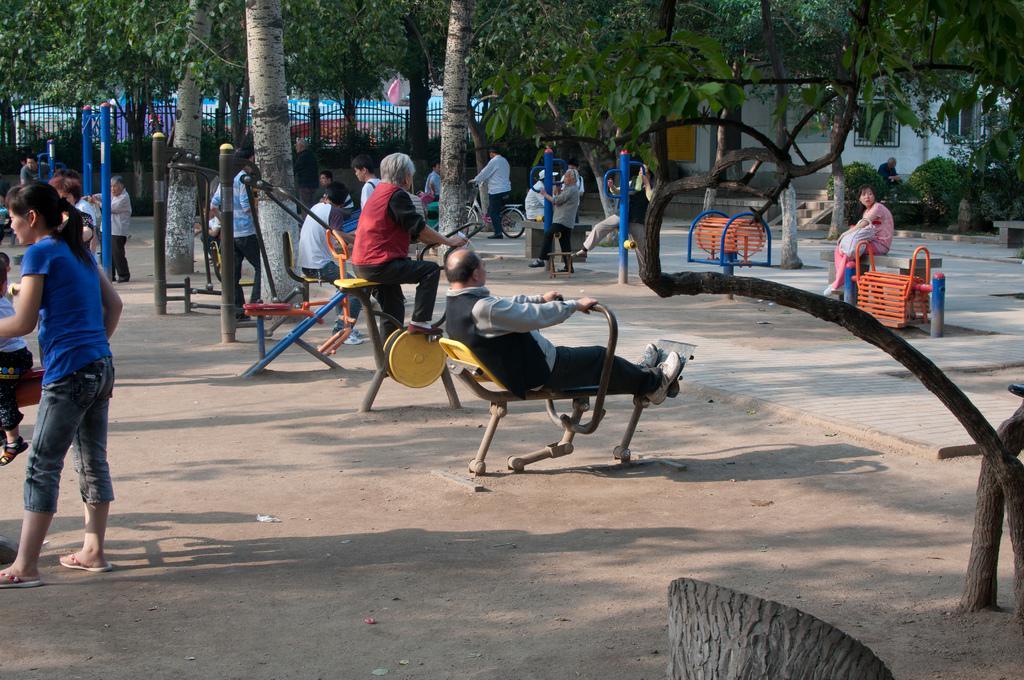Please provide a concise description of this image. In this image there are few people in the park, a few are playing with their children and few are doing exercise with some equipments. On the right side of the image there is a lady sat on the bench and a person riding a bicycle. In the background there are trees and a railing. 